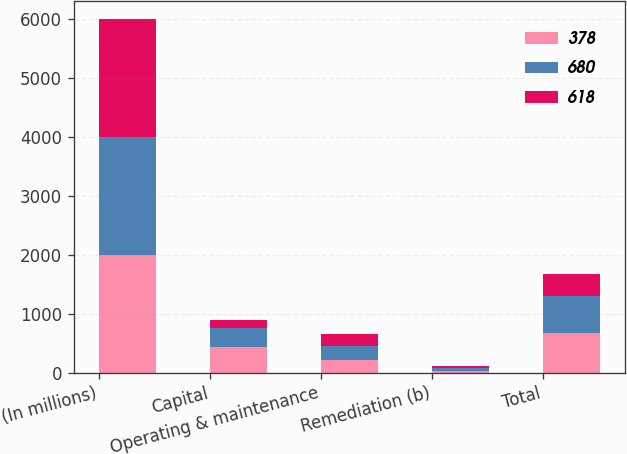Convert chart to OTSL. <chart><loc_0><loc_0><loc_500><loc_500><stacked_bar_chart><ecel><fcel>(In millions)<fcel>Capital<fcel>Operating & maintenance<fcel>Remediation (b)<fcel>Total<nl><fcel>378<fcel>2004<fcel>433<fcel>215<fcel>32<fcel>680<nl><fcel>680<fcel>2003<fcel>331<fcel>243<fcel>44<fcel>618<nl><fcel>618<fcel>2002<fcel>128<fcel>205<fcel>45<fcel>378<nl></chart> 